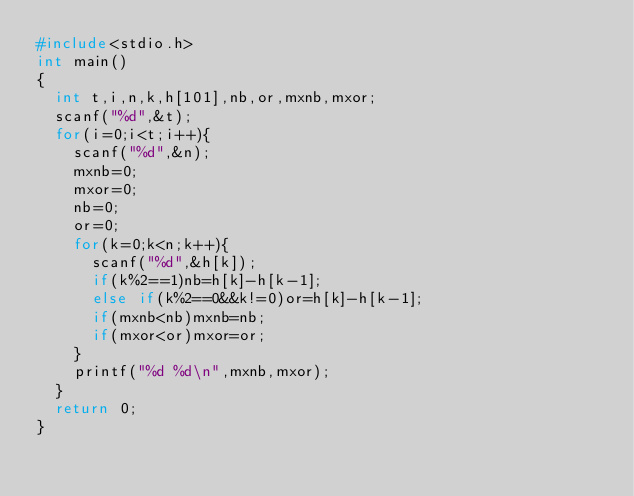<code> <loc_0><loc_0><loc_500><loc_500><_C_>#include<stdio.h>
int main()
{
  int t,i,n,k,h[101],nb,or,mxnb,mxor;
  scanf("%d",&t);
  for(i=0;i<t;i++){
    scanf("%d",&n);
    mxnb=0;
    mxor=0;
    nb=0;
    or=0;
    for(k=0;k<n;k++){
      scanf("%d",&h[k]);
      if(k%2==1)nb=h[k]-h[k-1];
      else if(k%2==0&&k!=0)or=h[k]-h[k-1];
      if(mxnb<nb)mxnb=nb;
      if(mxor<or)mxor=or;
    }
    printf("%d %d\n",mxnb,mxor);
  }
  return 0;
}</code> 